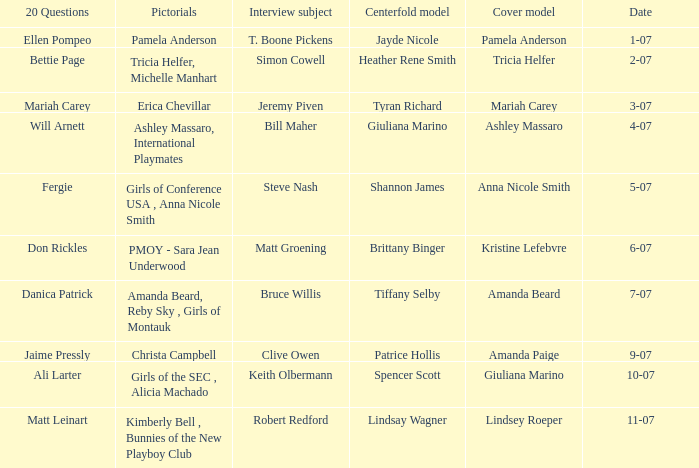List the pictorals from issues when lindsey roeper was the cover model. Kimberly Bell , Bunnies of the New Playboy Club. 